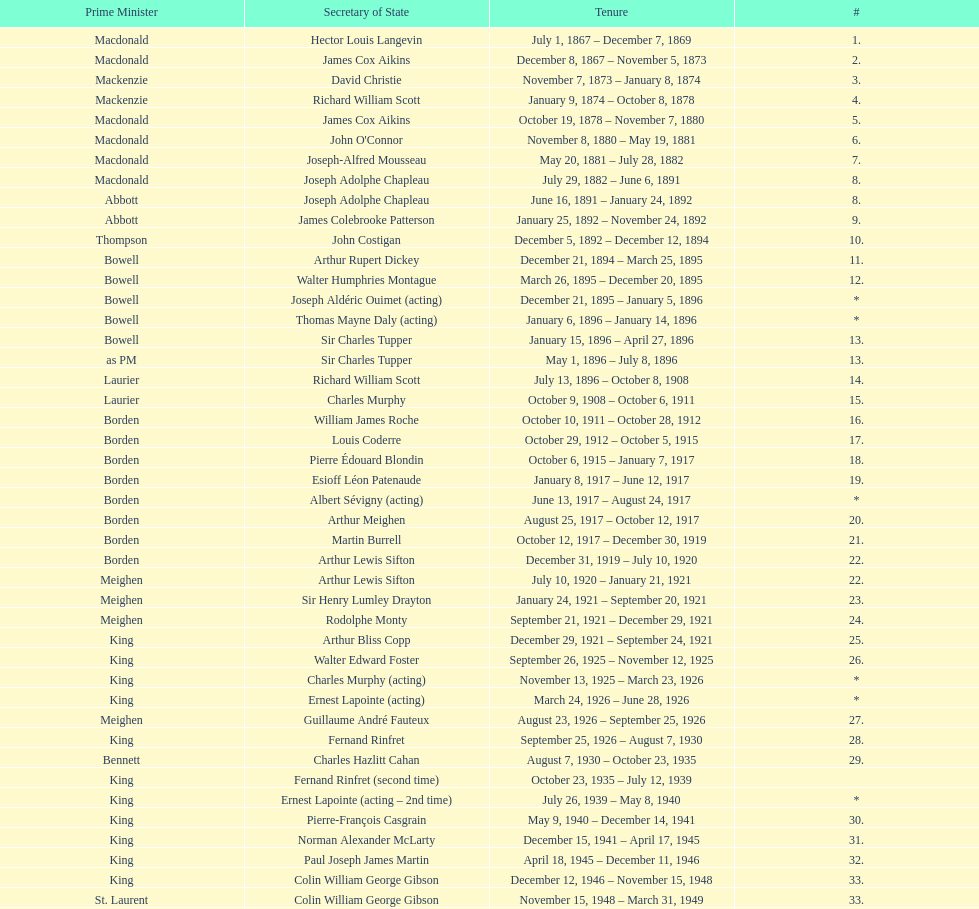What secretary of state served under both prime minister laurier and prime minister king? Charles Murphy. Could you help me parse every detail presented in this table? {'header': ['Prime Minister', 'Secretary of State', 'Tenure', '#'], 'rows': [['Macdonald', 'Hector Louis Langevin', 'July 1, 1867 – December 7, 1869', '1.'], ['Macdonald', 'James Cox Aikins', 'December 8, 1867 – November 5, 1873', '2.'], ['Mackenzie', 'David Christie', 'November 7, 1873 – January 8, 1874', '3.'], ['Mackenzie', 'Richard William Scott', 'January 9, 1874 – October 8, 1878', '4.'], ['Macdonald', 'James Cox Aikins', 'October 19, 1878 – November 7, 1880', '5.'], ['Macdonald', "John O'Connor", 'November 8, 1880 – May 19, 1881', '6.'], ['Macdonald', 'Joseph-Alfred Mousseau', 'May 20, 1881 – July 28, 1882', '7.'], ['Macdonald', 'Joseph Adolphe Chapleau', 'July 29, 1882 – June 6, 1891', '8.'], ['Abbott', 'Joseph Adolphe Chapleau', 'June 16, 1891 – January 24, 1892', '8.'], ['Abbott', 'James Colebrooke Patterson', 'January 25, 1892 – November 24, 1892', '9.'], ['Thompson', 'John Costigan', 'December 5, 1892 – December 12, 1894', '10.'], ['Bowell', 'Arthur Rupert Dickey', 'December 21, 1894 – March 25, 1895', '11.'], ['Bowell', 'Walter Humphries Montague', 'March 26, 1895 – December 20, 1895', '12.'], ['Bowell', 'Joseph Aldéric Ouimet (acting)', 'December 21, 1895 – January 5, 1896', '*'], ['Bowell', 'Thomas Mayne Daly (acting)', 'January 6, 1896 – January 14, 1896', '*'], ['Bowell', 'Sir Charles Tupper', 'January 15, 1896 – April 27, 1896', '13.'], ['as PM', 'Sir Charles Tupper', 'May 1, 1896 – July 8, 1896', '13.'], ['Laurier', 'Richard William Scott', 'July 13, 1896 – October 8, 1908', '14.'], ['Laurier', 'Charles Murphy', 'October 9, 1908 – October 6, 1911', '15.'], ['Borden', 'William James Roche', 'October 10, 1911 – October 28, 1912', '16.'], ['Borden', 'Louis Coderre', 'October 29, 1912 – October 5, 1915', '17.'], ['Borden', 'Pierre Édouard Blondin', 'October 6, 1915 – January 7, 1917', '18.'], ['Borden', 'Esioff Léon Patenaude', 'January 8, 1917 – June 12, 1917', '19.'], ['Borden', 'Albert Sévigny (acting)', 'June 13, 1917 – August 24, 1917', '*'], ['Borden', 'Arthur Meighen', 'August 25, 1917 – October 12, 1917', '20.'], ['Borden', 'Martin Burrell', 'October 12, 1917 – December 30, 1919', '21.'], ['Borden', 'Arthur Lewis Sifton', 'December 31, 1919 – July 10, 1920', '22.'], ['Meighen', 'Arthur Lewis Sifton', 'July 10, 1920 – January 21, 1921', '22.'], ['Meighen', 'Sir Henry Lumley Drayton', 'January 24, 1921 – September 20, 1921', '23.'], ['Meighen', 'Rodolphe Monty', 'September 21, 1921 – December 29, 1921', '24.'], ['King', 'Arthur Bliss Copp', 'December 29, 1921 – September 24, 1921', '25.'], ['King', 'Walter Edward Foster', 'September 26, 1925 – November 12, 1925', '26.'], ['King', 'Charles Murphy (acting)', 'November 13, 1925 – March 23, 1926', '*'], ['King', 'Ernest Lapointe (acting)', 'March 24, 1926 – June 28, 1926', '*'], ['Meighen', 'Guillaume André Fauteux', 'August 23, 1926 – September 25, 1926', '27.'], ['King', 'Fernand Rinfret', 'September 25, 1926 – August 7, 1930', '28.'], ['Bennett', 'Charles Hazlitt Cahan', 'August 7, 1930 – October 23, 1935', '29.'], ['King', 'Fernand Rinfret (second time)', 'October 23, 1935 – July 12, 1939', ''], ['King', 'Ernest Lapointe (acting – 2nd time)', 'July 26, 1939 – May 8, 1940', '*'], ['King', 'Pierre-François Casgrain', 'May 9, 1940 – December 14, 1941', '30.'], ['King', 'Norman Alexander McLarty', 'December 15, 1941 – April 17, 1945', '31.'], ['King', 'Paul Joseph James Martin', 'April 18, 1945 – December 11, 1946', '32.'], ['King', 'Colin William George Gibson', 'December 12, 1946 – November 15, 1948', '33.'], ['St. Laurent', 'Colin William George Gibson', 'November 15, 1948 – March 31, 1949', '33.'], ['St. Laurent', 'Frederick Gordon Bradley', 'March 31, 1949 – June 11, 1953', '34.'], ['St. Laurent', 'Jack Pickersgill', 'June 11, 1953 – June 30, 1954', '35.'], ['St. Laurent', 'Roch Pinard', 'July 1, 1954 – June 21, 1957', '36.'], ['Diefenbaker', 'Ellen Louks Fairclough', 'June 21, 1957 – May 11, 1958', '37.'], ['Diefenbaker', 'Henri Courtemanche', 'May 12, 1958 – June 19, 1960', '38.'], ['Diefenbaker', 'Léon Balcer (acting minister)', 'June 21, 1960 – October 10, 1960', '*'], ['Diefenbaker', 'Noël Dorion', 'October 11, 1960 – July 5, 1962', '39.'], ['Diefenbaker', 'Léon Balcer (acting minister – 2nd time)', 'July 11, 1962 – August 8, 1962', '*'], ['Diefenbaker', 'George Ernest Halpenny', 'August 9, 1962 – April 22, 1963', '40.'], ['Pearson', 'Jack Pickersgill (second time)', 'April 22, 1963 – February 2, 1964', ''], ['Pearson', 'Maurice Lamontagne', 'February 2, 1964 – December 17, 1965', '41.'], ['Pearson', 'Judy LaMarsh', 'December 17, 1965 – April 9, 1968', '42.'], ['Pearson', 'John Joseph Connolly (acting minister)', 'April 10, 1968 – April 20, 1968', '*'], ['Trudeau', 'Jean Marchand', 'April 20, 1968 – July 5, 1968', '43.'], ['Trudeau', 'Gérard Pelletier', 'July 5, 1968 – November 26, 1972', '44.'], ['Trudeau', 'James Hugh Faulkner', 'November 27, 1972 – September 13, 1976', '45.'], ['Trudeau', 'John Roberts', 'September 14, 1976 – June 3, 1979', '46.'], ['Clark', 'David MacDonald', 'June 4, 1979 – March 2, 1980', '47.'], ['Trudeau', 'Francis Fox', 'March 3, 1980 – September 21, 1981', '48.'], ['Trudeau', 'Gerald Regan', 'September 22, 1981 – October 5, 1982', '49.'], ['Trudeau', 'Serge Joyal', 'October 6, 1982 – June 29, 1984', '50.'], ['Turner', 'Serge Joyal', 'June 30, 1984 – September 16, 1984', '50.'], ['Mulroney', 'Walter McLean', 'September 17, 1984 – April 19, 1985', '51.'], ['Mulroney', 'Benoit Bouchard', 'April 20, 1985 – June 29, 1986', '52.'], ['Mulroney', 'David Crombie', 'June 30, 1986 – March 30, 1988', '53.'], ['Mulroney', 'Lucien Bouchard', 'March 31, 1988 – January 29, 1989', '54.'], ['Mulroney', 'Gerry Weiner', 'January 30, 1989 – April 20, 1991', '55.'], ['Mulroney', 'Robert de Cotret', 'April 21, 1991 – January 3, 1993', '56.'], ['Mulroney', 'Monique Landry', 'January 4, 1993 – June 24, 1993', '57.'], ['Campbell', 'Monique Landry', 'June 24, 1993 – November 3, 1993', '57.'], ['Chrétien', 'Sergio Marchi', 'November 4, 1993 – January 24, 1996', '58.'], ['Chrétien', 'Lucienne Robillard', 'January 25, 1996 – July 12, 1996', '59.']]} 